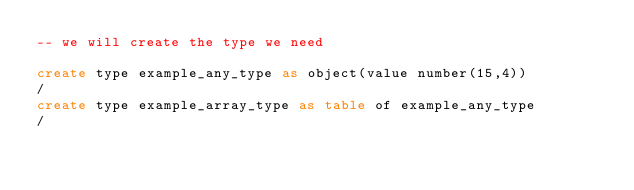Convert code to text. <code><loc_0><loc_0><loc_500><loc_500><_SQL_>-- we will create the type we need

create type example_any_type as object(value number(15,4))
/
create type example_array_type as table of example_any_type
/

</code> 